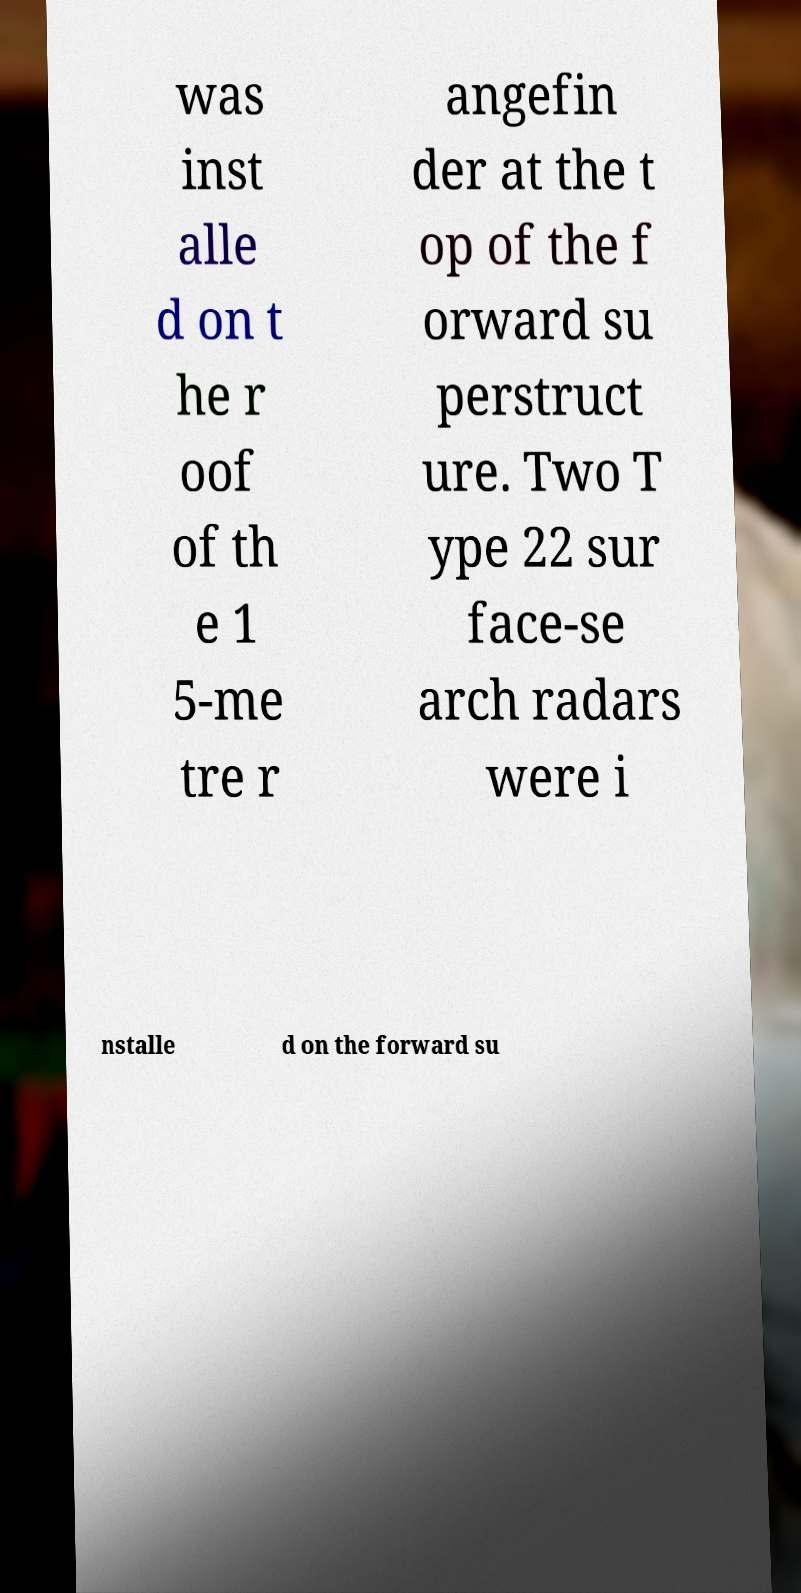Could you assist in decoding the text presented in this image and type it out clearly? was inst alle d on t he r oof of th e 1 5-me tre r angefin der at the t op of the f orward su perstruct ure. Two T ype 22 sur face-se arch radars were i nstalle d on the forward su 